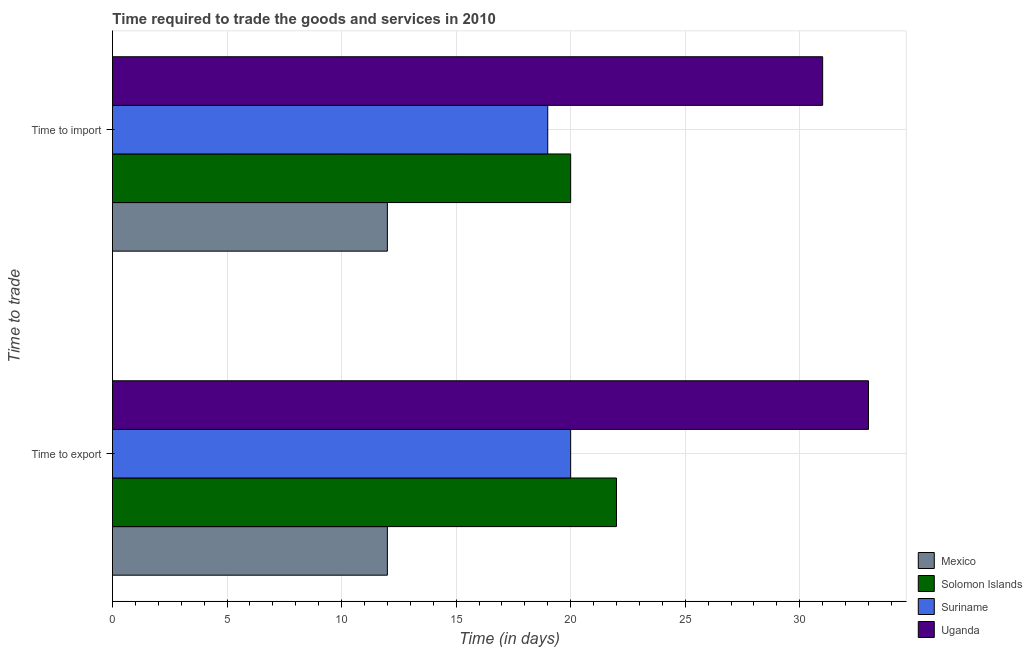Are the number of bars per tick equal to the number of legend labels?
Give a very brief answer. Yes. What is the label of the 1st group of bars from the top?
Provide a short and direct response. Time to import. What is the time to export in Uganda?
Your answer should be compact. 33. Across all countries, what is the maximum time to import?
Provide a short and direct response. 31. Across all countries, what is the minimum time to import?
Ensure brevity in your answer.  12. In which country was the time to import maximum?
Make the answer very short. Uganda. What is the total time to import in the graph?
Make the answer very short. 82. What is the difference between the time to import in Suriname and that in Mexico?
Ensure brevity in your answer.  7. What is the difference between the time to export in Solomon Islands and the time to import in Uganda?
Provide a succinct answer. -9. What is the average time to import per country?
Give a very brief answer. 20.5. What is the difference between the time to import and time to export in Uganda?
Your answer should be compact. -2. What is the ratio of the time to export in Uganda to that in Suriname?
Provide a succinct answer. 1.65. In how many countries, is the time to import greater than the average time to import taken over all countries?
Make the answer very short. 1. What does the 1st bar from the bottom in Time to export represents?
Make the answer very short. Mexico. How many bars are there?
Provide a succinct answer. 8. Are all the bars in the graph horizontal?
Ensure brevity in your answer.  Yes. How many countries are there in the graph?
Give a very brief answer. 4. Does the graph contain grids?
Your answer should be very brief. Yes. Where does the legend appear in the graph?
Offer a very short reply. Bottom right. What is the title of the graph?
Ensure brevity in your answer.  Time required to trade the goods and services in 2010. What is the label or title of the X-axis?
Ensure brevity in your answer.  Time (in days). What is the label or title of the Y-axis?
Your response must be concise. Time to trade. What is the Time (in days) in Mexico in Time to export?
Provide a short and direct response. 12. What is the Time (in days) of Solomon Islands in Time to export?
Provide a succinct answer. 22. What is the Time (in days) in Mexico in Time to import?
Offer a very short reply. 12. What is the Time (in days) of Suriname in Time to import?
Offer a terse response. 19. What is the Time (in days) of Uganda in Time to import?
Offer a very short reply. 31. Across all Time to trade, what is the maximum Time (in days) in Solomon Islands?
Your response must be concise. 22. Across all Time to trade, what is the minimum Time (in days) of Mexico?
Ensure brevity in your answer.  12. Across all Time to trade, what is the minimum Time (in days) of Solomon Islands?
Give a very brief answer. 20. What is the total Time (in days) in Mexico in the graph?
Make the answer very short. 24. What is the total Time (in days) in Uganda in the graph?
Your answer should be very brief. 64. What is the difference between the Time (in days) in Mexico in Time to export and that in Time to import?
Give a very brief answer. 0. What is the difference between the Time (in days) in Solomon Islands in Time to export and that in Time to import?
Ensure brevity in your answer.  2. What is the difference between the Time (in days) of Suriname in Time to export and that in Time to import?
Provide a short and direct response. 1. What is the difference between the Time (in days) of Mexico in Time to export and the Time (in days) of Solomon Islands in Time to import?
Your answer should be compact. -8. What is the difference between the Time (in days) in Mexico in Time to export and the Time (in days) in Uganda in Time to import?
Keep it short and to the point. -19. What is the difference between the Time (in days) in Solomon Islands in Time to export and the Time (in days) in Suriname in Time to import?
Keep it short and to the point. 3. What is the difference between the Time (in days) in Solomon Islands in Time to export and the Time (in days) in Uganda in Time to import?
Provide a short and direct response. -9. What is the difference between the Time (in days) in Suriname in Time to export and the Time (in days) in Uganda in Time to import?
Your answer should be very brief. -11. What is the average Time (in days) in Solomon Islands per Time to trade?
Your answer should be very brief. 21. What is the average Time (in days) in Suriname per Time to trade?
Make the answer very short. 19.5. What is the difference between the Time (in days) of Mexico and Time (in days) of Suriname in Time to export?
Your response must be concise. -8. What is the difference between the Time (in days) in Mexico and Time (in days) in Uganda in Time to export?
Keep it short and to the point. -21. What is the difference between the Time (in days) of Solomon Islands and Time (in days) of Uganda in Time to export?
Give a very brief answer. -11. What is the difference between the Time (in days) in Mexico and Time (in days) in Uganda in Time to import?
Ensure brevity in your answer.  -19. What is the difference between the Time (in days) of Solomon Islands and Time (in days) of Uganda in Time to import?
Keep it short and to the point. -11. What is the difference between the Time (in days) in Suriname and Time (in days) in Uganda in Time to import?
Provide a succinct answer. -12. What is the ratio of the Time (in days) of Solomon Islands in Time to export to that in Time to import?
Your response must be concise. 1.1. What is the ratio of the Time (in days) in Suriname in Time to export to that in Time to import?
Your answer should be compact. 1.05. What is the ratio of the Time (in days) of Uganda in Time to export to that in Time to import?
Your answer should be very brief. 1.06. What is the difference between the highest and the second highest Time (in days) of Suriname?
Make the answer very short. 1. What is the difference between the highest and the lowest Time (in days) in Mexico?
Give a very brief answer. 0. What is the difference between the highest and the lowest Time (in days) of Suriname?
Provide a short and direct response. 1. 